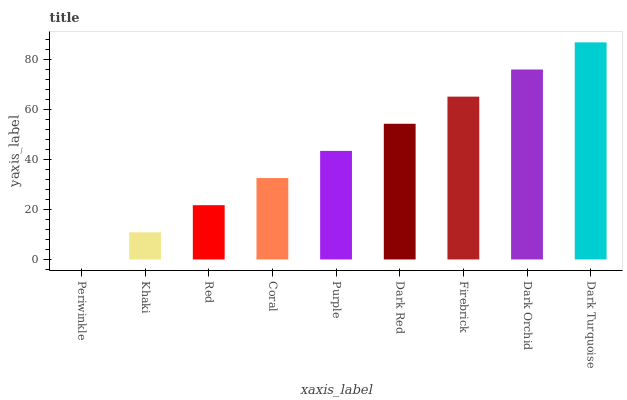Is Periwinkle the minimum?
Answer yes or no. Yes. Is Dark Turquoise the maximum?
Answer yes or no. Yes. Is Khaki the minimum?
Answer yes or no. No. Is Khaki the maximum?
Answer yes or no. No. Is Khaki greater than Periwinkle?
Answer yes or no. Yes. Is Periwinkle less than Khaki?
Answer yes or no. Yes. Is Periwinkle greater than Khaki?
Answer yes or no. No. Is Khaki less than Periwinkle?
Answer yes or no. No. Is Purple the high median?
Answer yes or no. Yes. Is Purple the low median?
Answer yes or no. Yes. Is Dark Turquoise the high median?
Answer yes or no. No. Is Firebrick the low median?
Answer yes or no. No. 